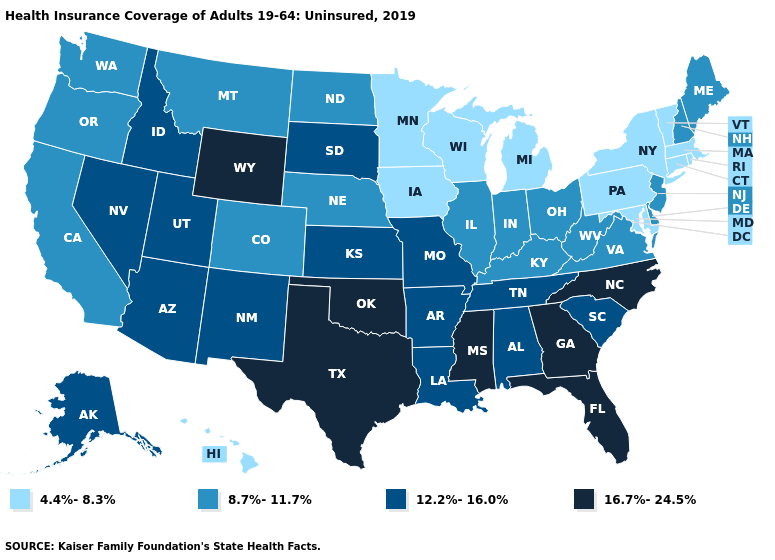Does West Virginia have a higher value than Virginia?
Keep it brief. No. What is the highest value in states that border Nebraska?
Short answer required. 16.7%-24.5%. Does Washington have a lower value than Utah?
Be succinct. Yes. What is the lowest value in states that border Michigan?
Give a very brief answer. 4.4%-8.3%. Does Michigan have the same value as North Carolina?
Answer briefly. No. Does Mississippi have the same value as Minnesota?
Short answer required. No. What is the value of Kansas?
Give a very brief answer. 12.2%-16.0%. Does Colorado have the highest value in the USA?
Short answer required. No. Name the states that have a value in the range 12.2%-16.0%?
Give a very brief answer. Alabama, Alaska, Arizona, Arkansas, Idaho, Kansas, Louisiana, Missouri, Nevada, New Mexico, South Carolina, South Dakota, Tennessee, Utah. Name the states that have a value in the range 12.2%-16.0%?
Keep it brief. Alabama, Alaska, Arizona, Arkansas, Idaho, Kansas, Louisiana, Missouri, Nevada, New Mexico, South Carolina, South Dakota, Tennessee, Utah. What is the lowest value in the South?
Give a very brief answer. 4.4%-8.3%. What is the highest value in the USA?
Be succinct. 16.7%-24.5%. Does Vermont have the highest value in the Northeast?
Answer briefly. No. Does Oklahoma have the same value as Mississippi?
Concise answer only. Yes. What is the value of Illinois?
Short answer required. 8.7%-11.7%. 